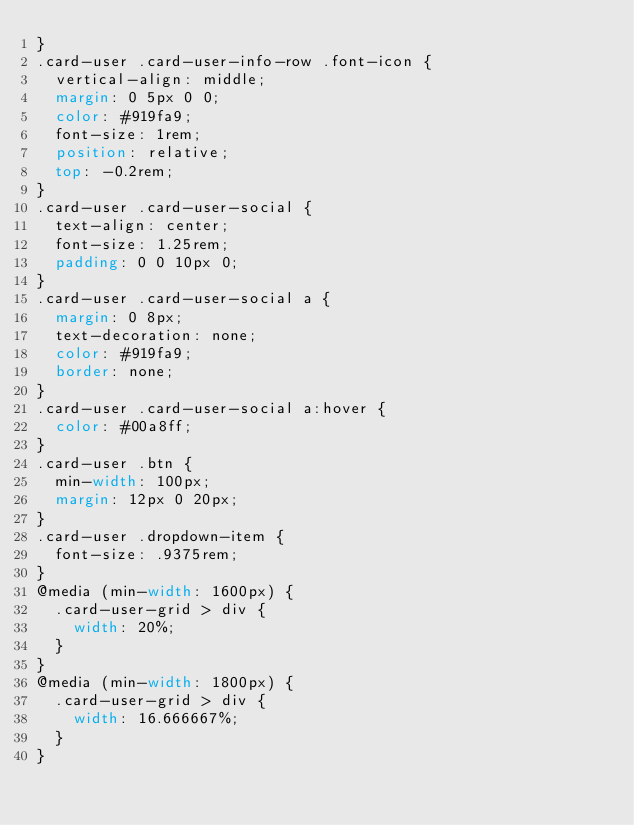Convert code to text. <code><loc_0><loc_0><loc_500><loc_500><_CSS_>}
.card-user .card-user-info-row .font-icon {
  vertical-align: middle;
  margin: 0 5px 0 0;
  color: #919fa9;
  font-size: 1rem;
  position: relative;
  top: -0.2rem;
}
.card-user .card-user-social {
  text-align: center;
  font-size: 1.25rem;
  padding: 0 0 10px 0;
}
.card-user .card-user-social a {
  margin: 0 8px;
  text-decoration: none;
  color: #919fa9;
  border: none;
}
.card-user .card-user-social a:hover {
  color: #00a8ff;
}
.card-user .btn {
  min-width: 100px;
  margin: 12px 0 20px;
}
.card-user .dropdown-item {
  font-size: .9375rem;
}
@media (min-width: 1600px) {
  .card-user-grid > div {
    width: 20%;
  }
}
@media (min-width: 1800px) {
  .card-user-grid > div {
    width: 16.666667%;
  }
}
</code> 